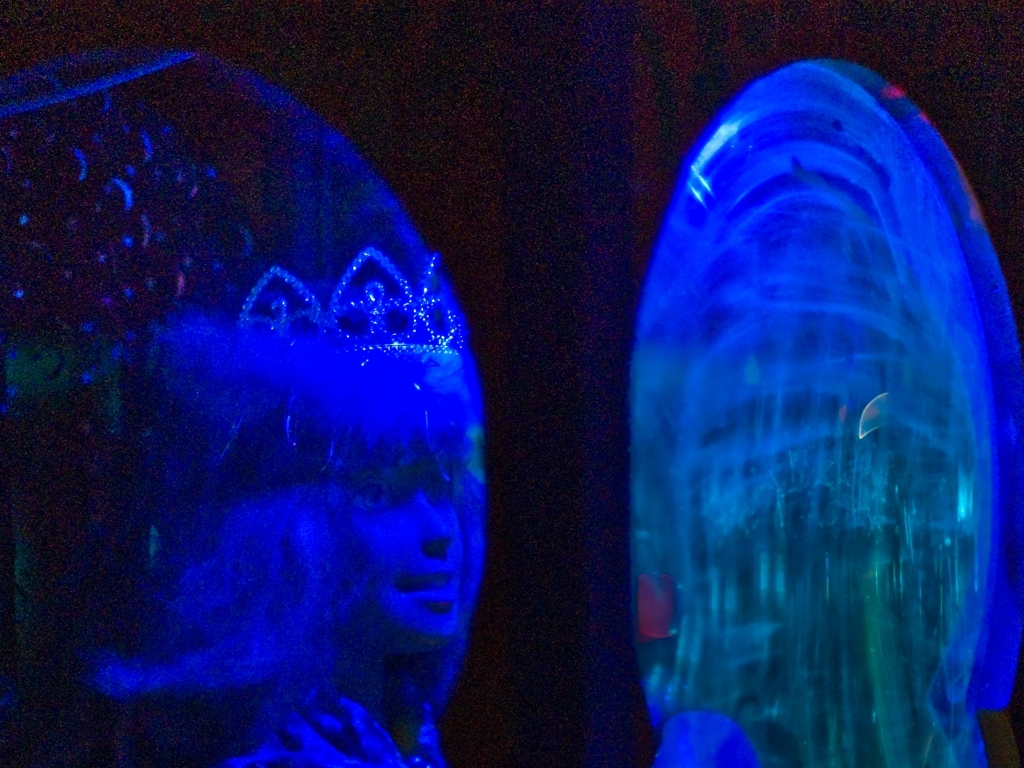What is the theme or event that this image might be associated with? Considering the adornment on the head which resembles a tiara and the overall dreamy quality of the photo, it's possible that the image is associated with an event like a costume party, theatrical performance, or a festival that involves creative expression and elaborate dress-up, all set within a space with dramatic lighting to enhance the mood. 